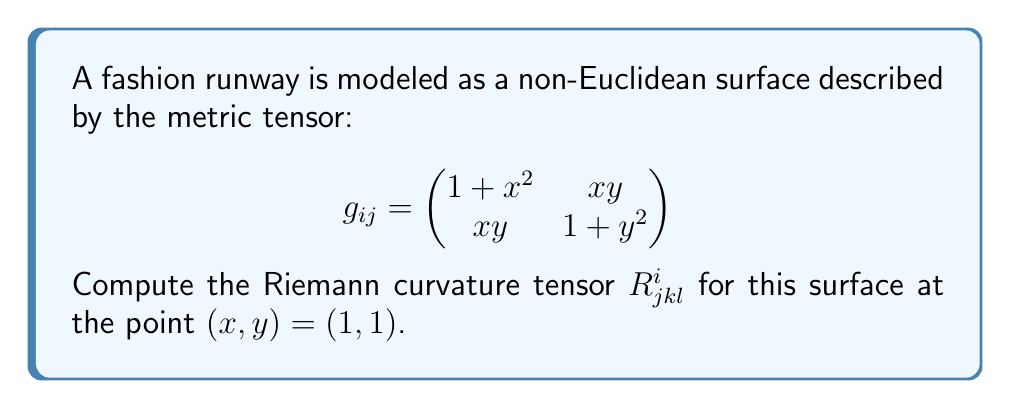Give your solution to this math problem. To compute the Riemann curvature tensor, we'll follow these steps:

1) First, we need to calculate the Christoffel symbols $\Gamma^i_{jk}$:
   $$\Gamma^i_{jk} = \frac{1}{2}g^{im}(\partial_j g_{km} + \partial_k g_{jm} - \partial_m g_{jk})$$

2) Calculate the inverse metric tensor $g^{ij}$:
   $$g^{ij} = \frac{1}{\det(g_{ij})}\begin{pmatrix}
   1+y^2 & -xy \\
   -xy & 1+x^2
   \end{pmatrix}$$
   
   At $(1,1)$: $\det(g_{ij}) = (1+1^2)(1+1^2) - 1^2 = 3$

3) Calculate the partial derivatives of $g_{ij}$:
   $$\partial_x g_{11} = 2x, \partial_y g_{11} = 0$$
   $$\partial_x g_{12} = y, \partial_y g_{12} = x$$
   $$\partial_x g_{22} = 0, \partial_y g_{22} = 2y$$

4) Using these, calculate the Christoffel symbols at $(1,1)$:
   $$\Gamma^1_{11} = \frac{2}{3}, \Gamma^1_{12} = \Gamma^1_{21} = \frac{1}{3}, \Gamma^1_{22} = -\frac{1}{3}$$
   $$\Gamma^2_{11} = -\frac{1}{3}, \Gamma^2_{12} = \Gamma^2_{21} = \frac{1}{3}, \Gamma^2_{22} = \frac{2}{3}$$

5) Now, we can compute the Riemann curvature tensor:
   $$R^i_{jkl} = \partial_k \Gamma^i_{jl} - \partial_l \Gamma^i_{jk} + \Gamma^m_{jl}\Gamma^i_{mk} - \Gamma^m_{jk}\Gamma^i_{ml}$$

6) Calculating each component at $(1,1)$:
   $$R^1_{212} = -\frac{1}{3}, R^1_{221} = \frac{1}{3}$$
   $$R^2_{112} = \frac{1}{3}, R^2_{121} = -\frac{1}{3}$$
   
   All other components are zero due to symmetry or antisymmetry properties.
Answer: $R^1_{212} = -\frac{1}{3}, R^1_{221} = \frac{1}{3}, R^2_{112} = \frac{1}{3}, R^2_{121} = -\frac{1}{3}$, others $= 0$ 